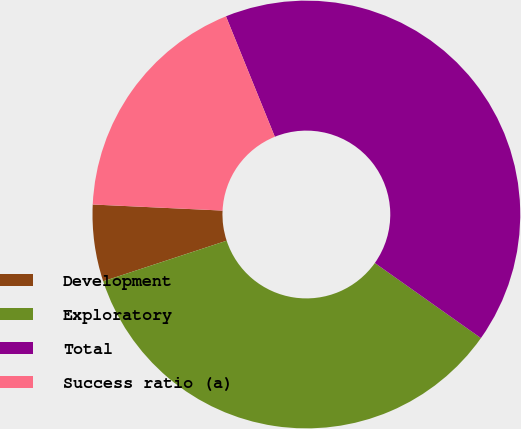Convert chart. <chart><loc_0><loc_0><loc_500><loc_500><pie_chart><fcel>Development<fcel>Exploratory<fcel>Total<fcel>Success ratio (a)<nl><fcel>5.8%<fcel>35.14%<fcel>40.94%<fcel>18.12%<nl></chart> 